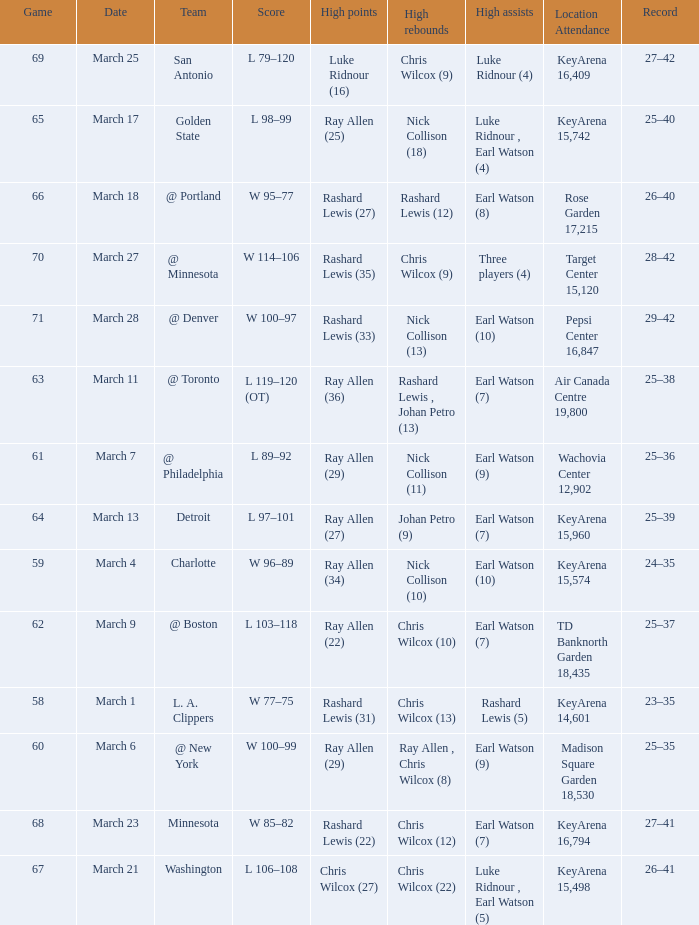What was the record after the game against Washington? 26–41. 